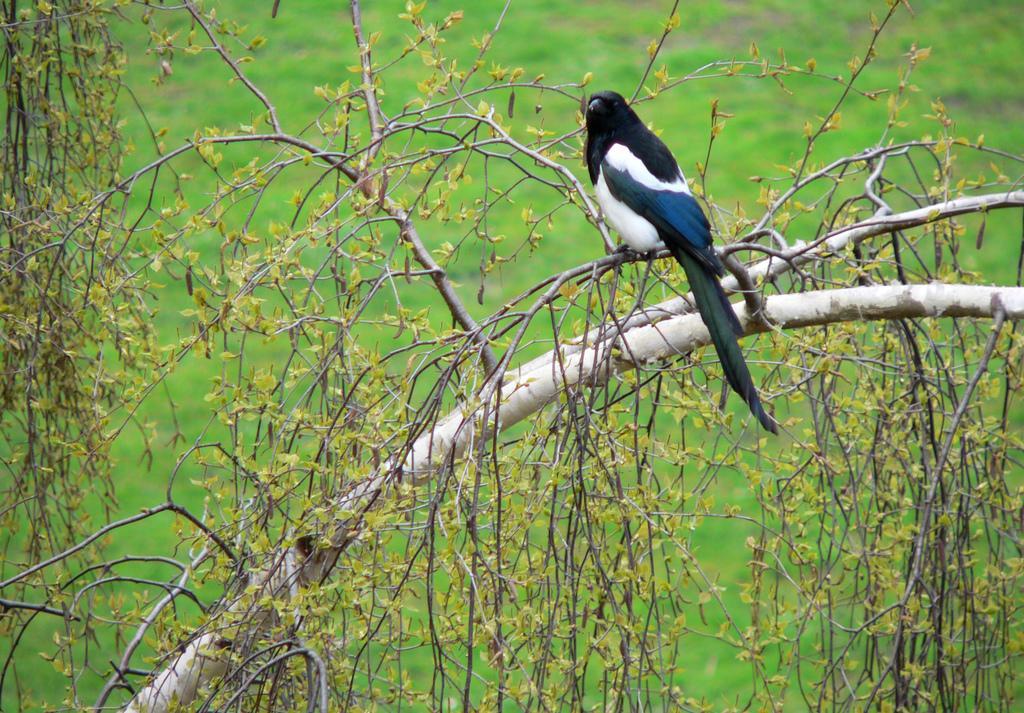Can you describe this image briefly? In the picture we can see a bird sitting on the plant, the bird is black and some part of white in color and in the background we can see a grass surface which is not clearly visible. 